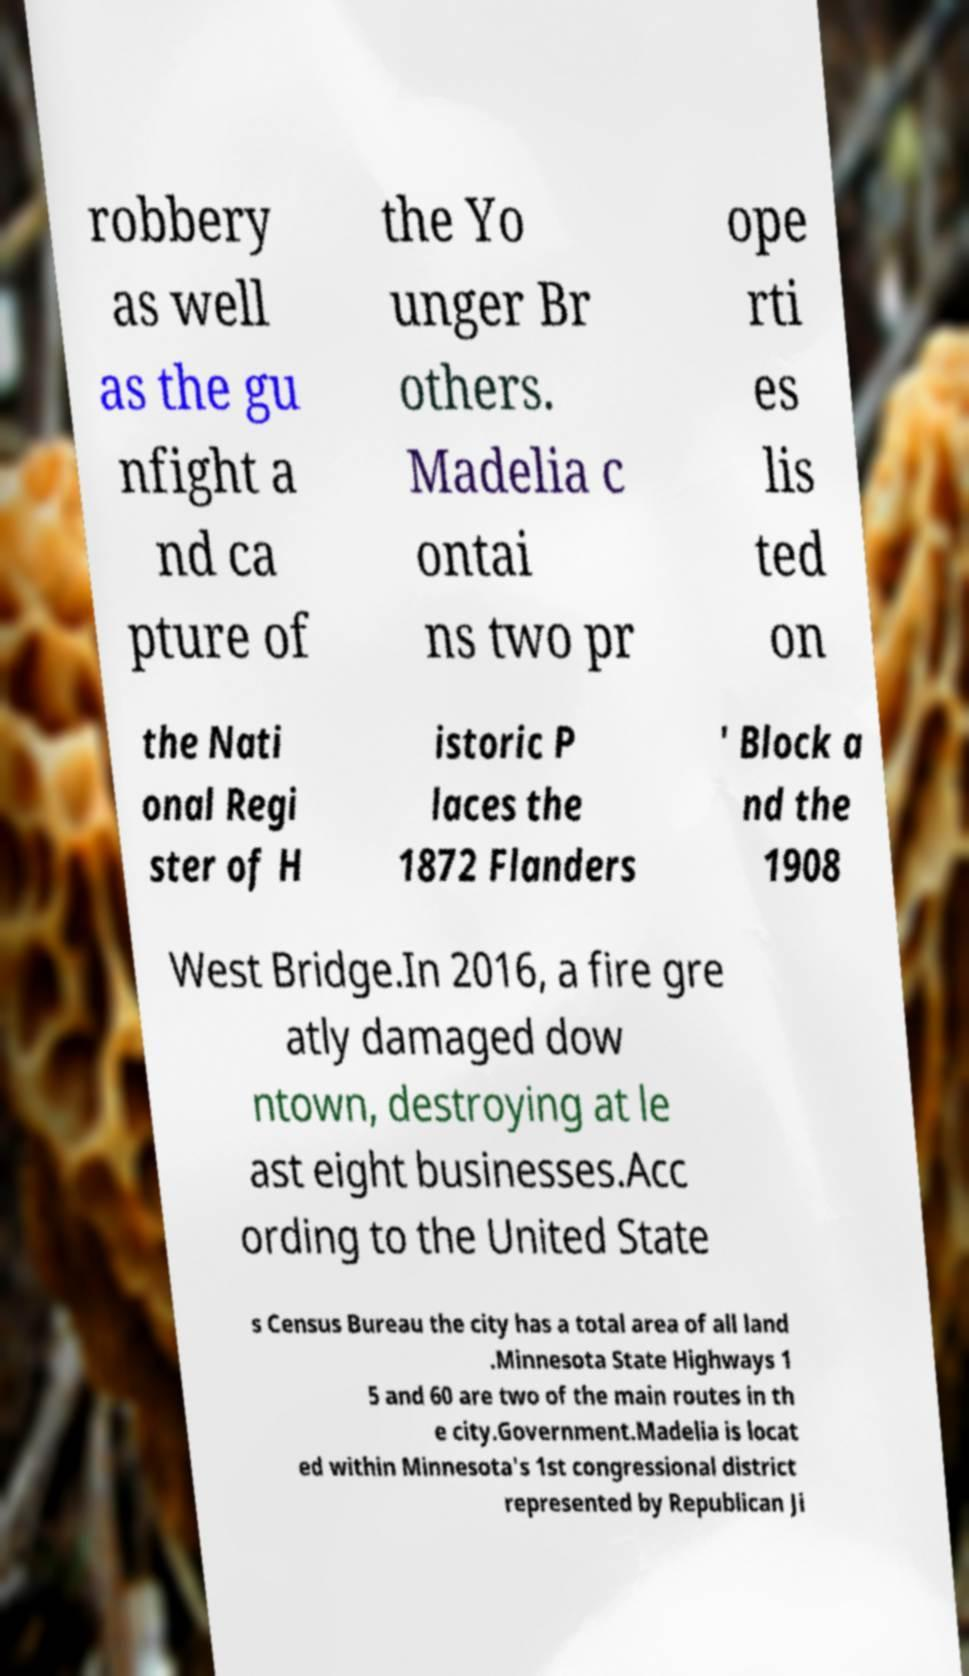I need the written content from this picture converted into text. Can you do that? robbery as well as the gu nfight a nd ca pture of the Yo unger Br others. Madelia c ontai ns two pr ope rti es lis ted on the Nati onal Regi ster of H istoric P laces the 1872 Flanders ' Block a nd the 1908 West Bridge.In 2016, a fire gre atly damaged dow ntown, destroying at le ast eight businesses.Acc ording to the United State s Census Bureau the city has a total area of all land .Minnesota State Highways 1 5 and 60 are two of the main routes in th e city.Government.Madelia is locat ed within Minnesota's 1st congressional district represented by Republican Ji 